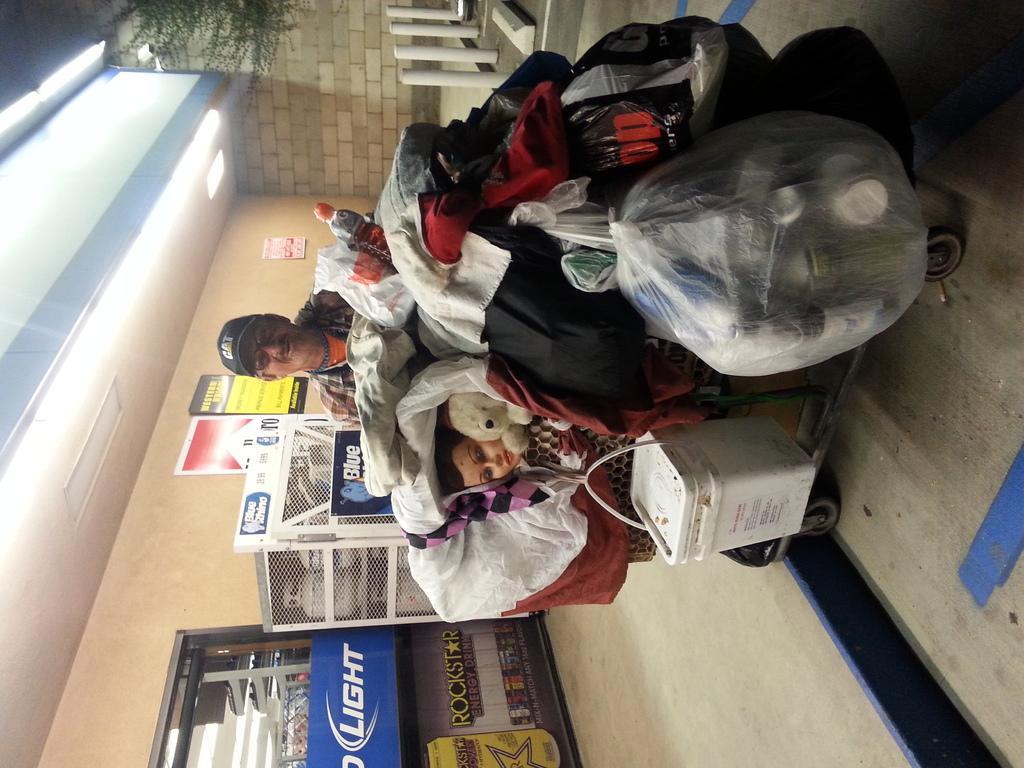Can you describe this image briefly? The image is inverted. On a trolley there are many clothes, toys, basket, polythene bags are there. A person is standing behind the trolley. He is wearing cap. In the bottom there are racks. On the roof there are lights. In the background there is wall. 